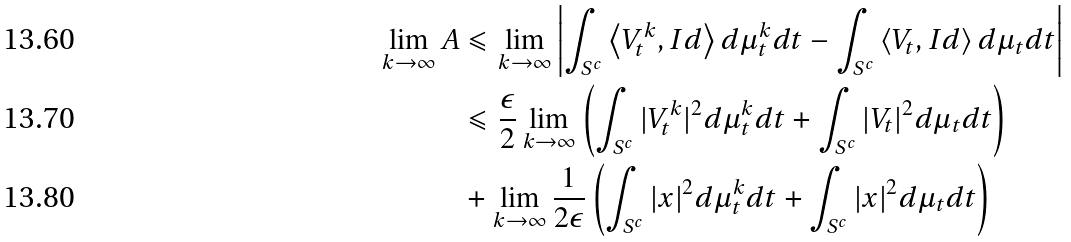Convert formula to latex. <formula><loc_0><loc_0><loc_500><loc_500>\lim _ { k \to \infty } A & \leqslant \lim _ { k \to \infty } \left | \int _ { S ^ { c } } \left \langle V _ { t } ^ { k } , I d \right \rangle d \mu _ { t } ^ { k } d t - \int _ { S ^ { c } } \left \langle V _ { t } , I d \right \rangle d \mu _ { t } d t \right | \\ & \leqslant \frac { \epsilon } { 2 } \lim _ { k \to \infty } \left ( \int _ { S ^ { c } } | V _ { t } ^ { k } | ^ { 2 } d \mu _ { t } ^ { k } d t + \int _ { S ^ { c } } | V _ { t } | ^ { 2 } d \mu _ { t } d t \right ) \\ & + \lim _ { k \to \infty } \frac { 1 } { 2 \epsilon } \left ( \int _ { S ^ { c } } | x | ^ { 2 } d \mu _ { t } ^ { k } d t + \int _ { S ^ { c } } | x | ^ { 2 } d \mu _ { t } d t \right )</formula> 